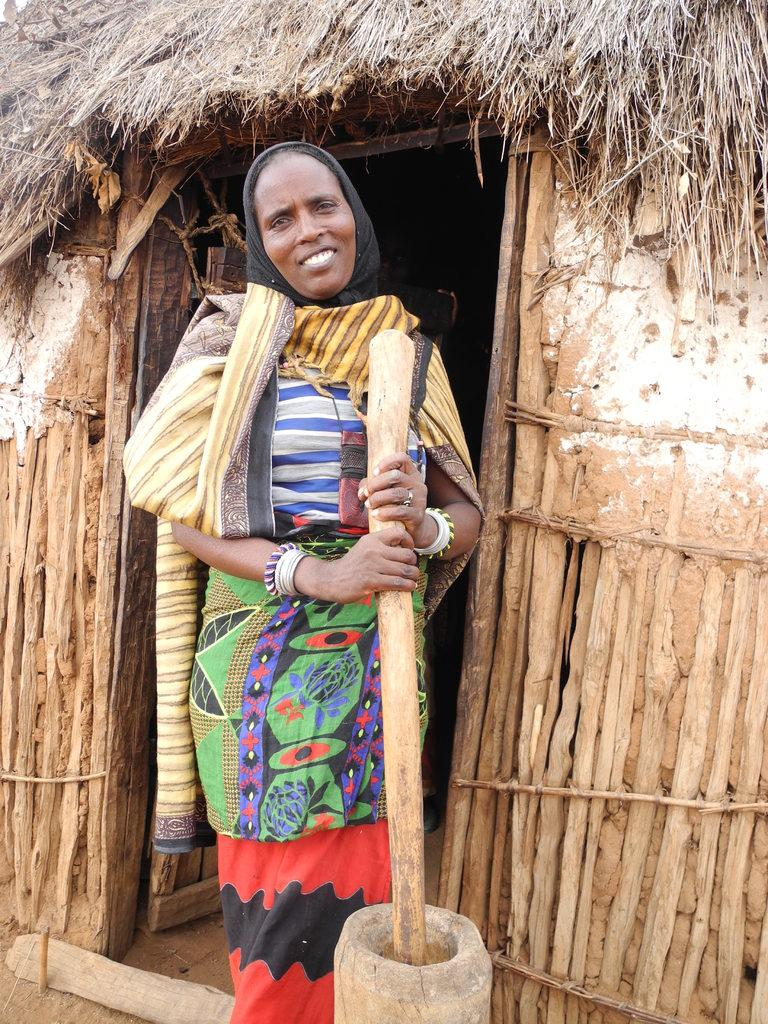Who is present in the image? There is a lady in the image. What is the lady holding in her hand? The lady is holding an object in her hand. What type of structure can be seen in the image? There is a hut in the image. What type of agreement is being signed by the lady in the image? There is no indication in the image that the lady is signing any agreement. 